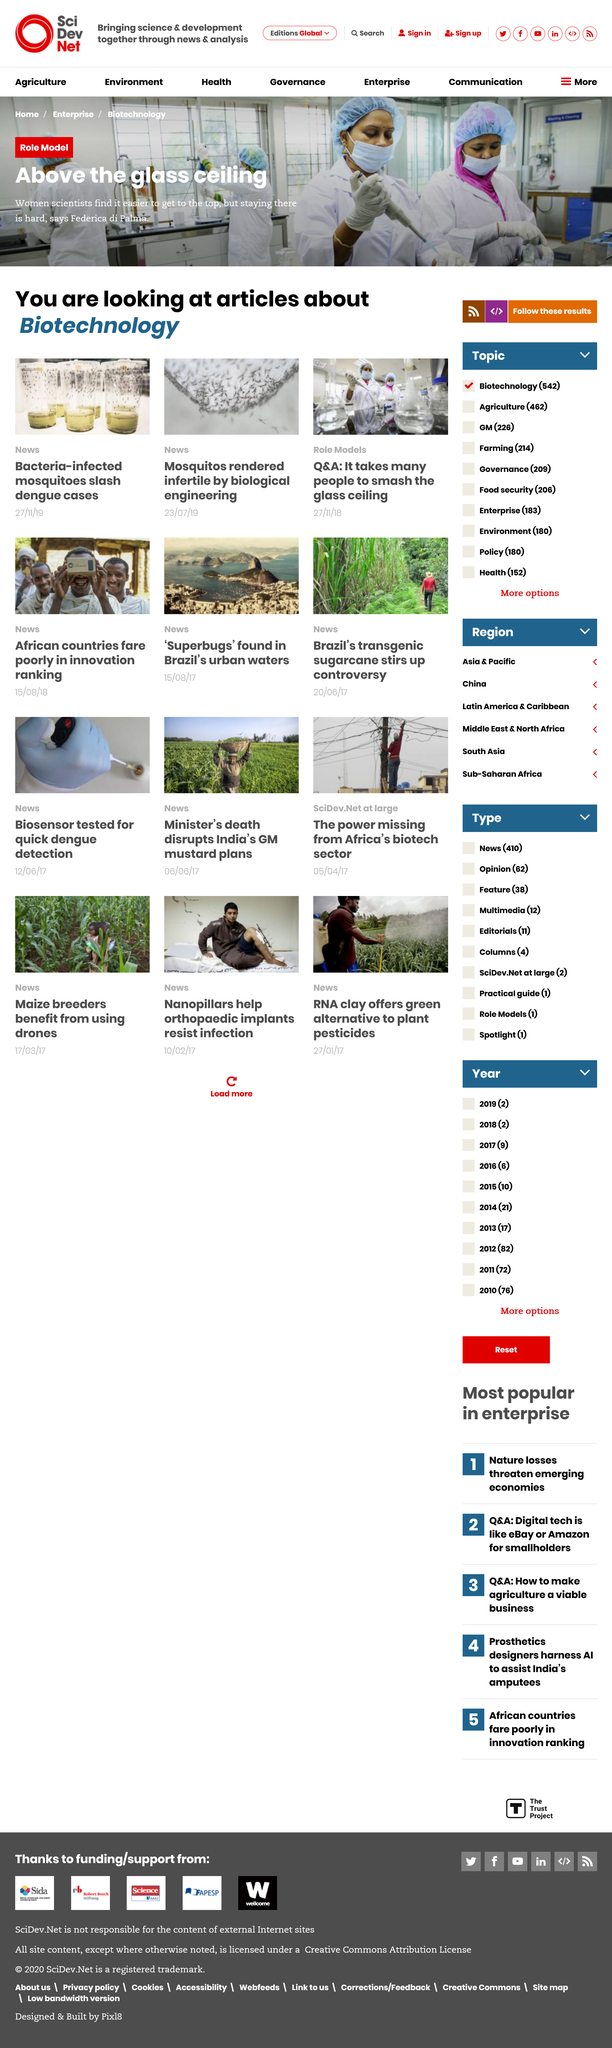Outline some significant characteristics in this image. The image at the top of the page depicts women scientists engaged in various research activities, and it is unclear what the specific topic or context of the image is. The current page features articles that pertain to biotechnology and related topics. The articles displayed on this page are news articles and an article on role models. 